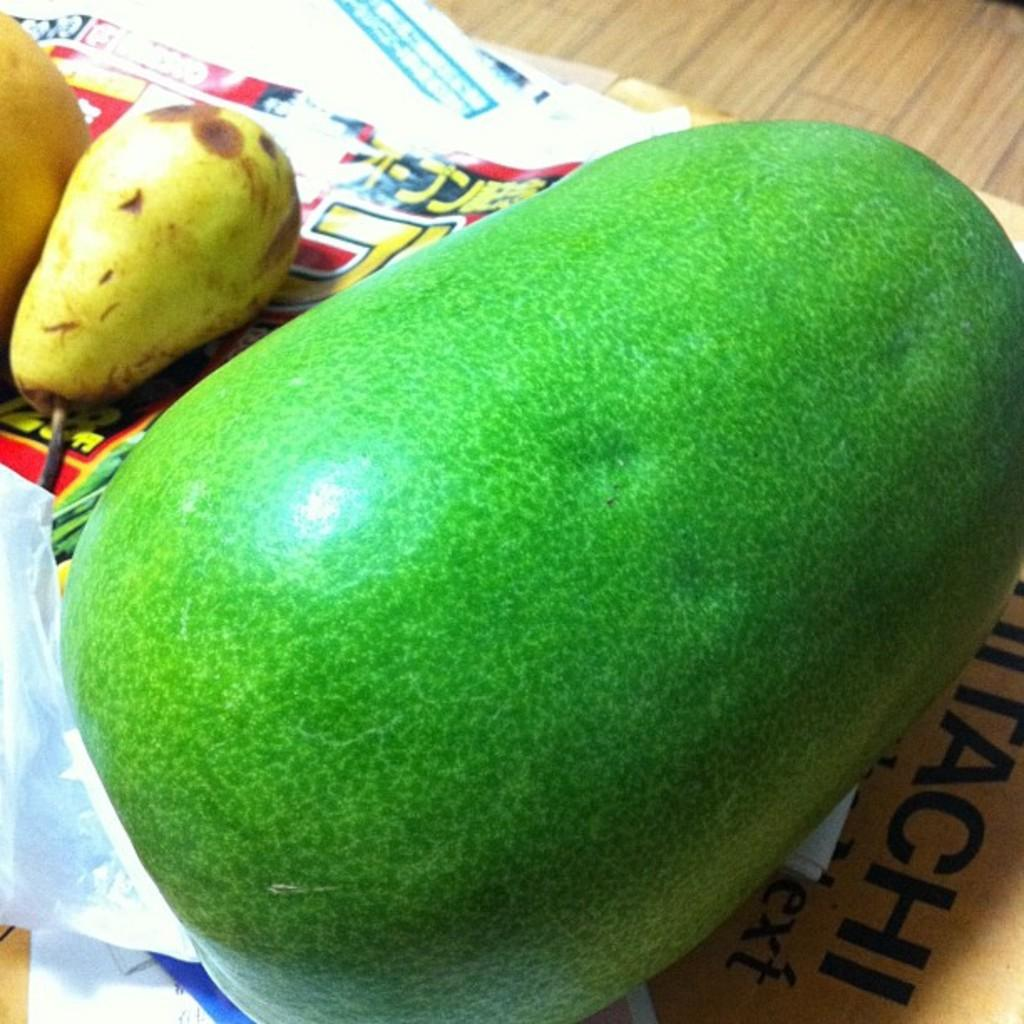What type of food can be seen in the image? There are fruits in the image. What is the surface made of that the objects are placed on? The objects are placed on a wooden surface in the image. What type of legal advice is the tiger providing in the image? There is no tiger or legal advice present in the image. What is the price of the fruits in the image? The price of the fruits is not mentioned in the image. 